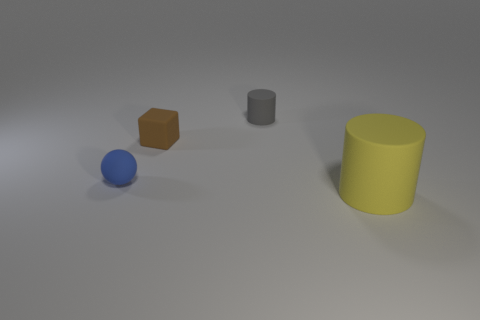Subtract all purple blocks. Subtract all gray cylinders. How many blocks are left? 1 Add 1 blue cubes. How many objects exist? 5 Subtract all cubes. How many objects are left? 3 Subtract 0 purple cylinders. How many objects are left? 4 Subtract all yellow rubber cylinders. Subtract all brown rubber things. How many objects are left? 2 Add 3 balls. How many balls are left? 4 Add 1 large yellow cubes. How many large yellow cubes exist? 1 